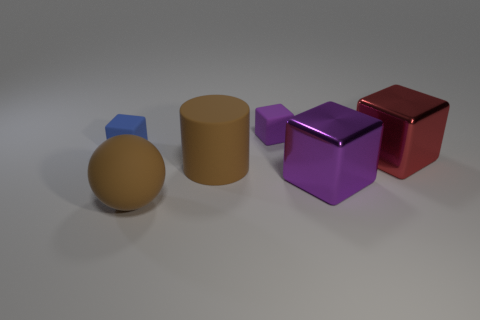There is a matte thing that is right of the brown cylinder; does it have the same size as the big matte cylinder?
Provide a succinct answer. No. Are there fewer large green rubber balls than balls?
Your response must be concise. Yes. Is there a brown cylinder made of the same material as the big brown ball?
Your answer should be very brief. Yes. There is a small rubber object behind the small blue matte object; what is its shape?
Provide a succinct answer. Cube. Does the big cube that is in front of the red thing have the same color as the large cylinder?
Provide a short and direct response. No. Are there fewer matte blocks to the left of the blue matte block than big rubber spheres?
Keep it short and to the point. Yes. There is a big object that is made of the same material as the big brown cylinder; what color is it?
Ensure brevity in your answer.  Brown. How big is the purple block that is in front of the small blue cube?
Give a very brief answer. Large. Is the big brown ball made of the same material as the red cube?
Your answer should be very brief. No. Is there a large red shiny block that is right of the large object that is in front of the large metallic cube in front of the red object?
Your response must be concise. Yes. 